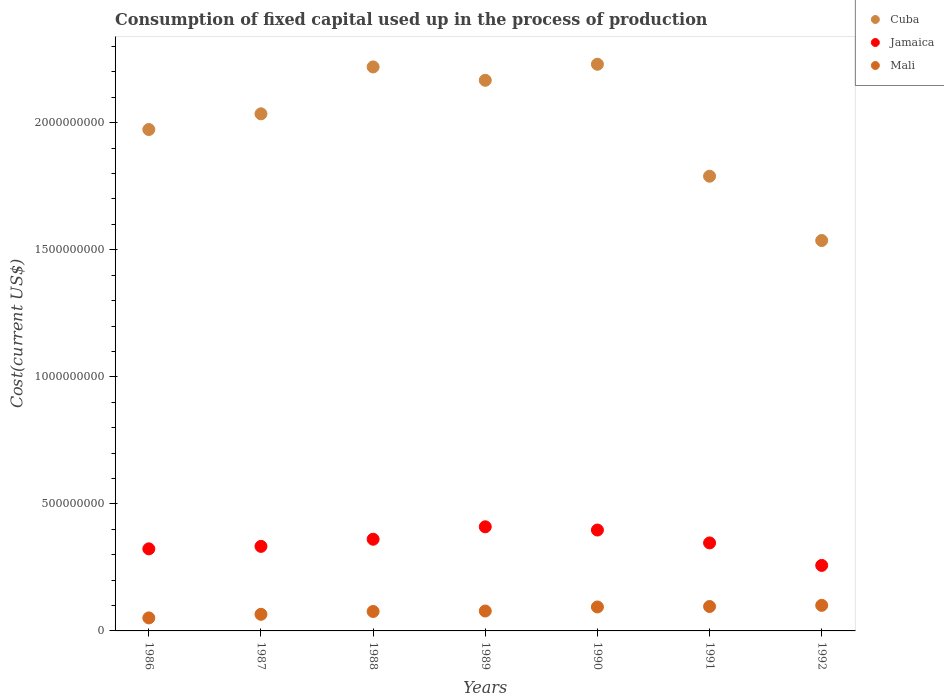Is the number of dotlines equal to the number of legend labels?
Your response must be concise. Yes. What is the amount consumed in the process of production in Mali in 1991?
Provide a short and direct response. 9.61e+07. Across all years, what is the maximum amount consumed in the process of production in Cuba?
Provide a short and direct response. 2.23e+09. Across all years, what is the minimum amount consumed in the process of production in Mali?
Provide a short and direct response. 5.12e+07. In which year was the amount consumed in the process of production in Jamaica maximum?
Your answer should be compact. 1989. What is the total amount consumed in the process of production in Cuba in the graph?
Give a very brief answer. 1.40e+1. What is the difference between the amount consumed in the process of production in Mali in 1989 and that in 1990?
Provide a succinct answer. -1.59e+07. What is the difference between the amount consumed in the process of production in Jamaica in 1988 and the amount consumed in the process of production in Mali in 1989?
Offer a terse response. 2.82e+08. What is the average amount consumed in the process of production in Jamaica per year?
Keep it short and to the point. 3.47e+08. In the year 1988, what is the difference between the amount consumed in the process of production in Jamaica and amount consumed in the process of production in Cuba?
Ensure brevity in your answer.  -1.86e+09. In how many years, is the amount consumed in the process of production in Mali greater than 100000000 US$?
Your response must be concise. 1. What is the ratio of the amount consumed in the process of production in Jamaica in 1986 to that in 1992?
Offer a terse response. 1.25. What is the difference between the highest and the second highest amount consumed in the process of production in Cuba?
Give a very brief answer. 1.05e+07. What is the difference between the highest and the lowest amount consumed in the process of production in Cuba?
Give a very brief answer. 6.94e+08. Is it the case that in every year, the sum of the amount consumed in the process of production in Cuba and amount consumed in the process of production in Mali  is greater than the amount consumed in the process of production in Jamaica?
Offer a terse response. Yes. Does the amount consumed in the process of production in Mali monotonically increase over the years?
Your answer should be compact. Yes. Is the amount consumed in the process of production in Mali strictly greater than the amount consumed in the process of production in Jamaica over the years?
Your response must be concise. No. Is the amount consumed in the process of production in Jamaica strictly less than the amount consumed in the process of production in Mali over the years?
Keep it short and to the point. No. What is the difference between two consecutive major ticks on the Y-axis?
Offer a very short reply. 5.00e+08. Are the values on the major ticks of Y-axis written in scientific E-notation?
Offer a terse response. No. Does the graph contain any zero values?
Provide a succinct answer. No. What is the title of the graph?
Your response must be concise. Consumption of fixed capital used up in the process of production. Does "High income: OECD" appear as one of the legend labels in the graph?
Your response must be concise. No. What is the label or title of the X-axis?
Make the answer very short. Years. What is the label or title of the Y-axis?
Make the answer very short. Cost(current US$). What is the Cost(current US$) of Cuba in 1986?
Make the answer very short. 1.97e+09. What is the Cost(current US$) in Jamaica in 1986?
Provide a short and direct response. 3.23e+08. What is the Cost(current US$) in Mali in 1986?
Make the answer very short. 5.12e+07. What is the Cost(current US$) in Cuba in 1987?
Give a very brief answer. 2.04e+09. What is the Cost(current US$) of Jamaica in 1987?
Offer a very short reply. 3.33e+08. What is the Cost(current US$) of Mali in 1987?
Provide a succinct answer. 6.54e+07. What is the Cost(current US$) of Cuba in 1988?
Offer a terse response. 2.22e+09. What is the Cost(current US$) of Jamaica in 1988?
Make the answer very short. 3.61e+08. What is the Cost(current US$) in Mali in 1988?
Keep it short and to the point. 7.65e+07. What is the Cost(current US$) of Cuba in 1989?
Offer a terse response. 2.17e+09. What is the Cost(current US$) in Jamaica in 1989?
Ensure brevity in your answer.  4.10e+08. What is the Cost(current US$) of Mali in 1989?
Your answer should be compact. 7.84e+07. What is the Cost(current US$) of Cuba in 1990?
Provide a short and direct response. 2.23e+09. What is the Cost(current US$) of Jamaica in 1990?
Ensure brevity in your answer.  3.97e+08. What is the Cost(current US$) in Mali in 1990?
Ensure brevity in your answer.  9.43e+07. What is the Cost(current US$) of Cuba in 1991?
Give a very brief answer. 1.79e+09. What is the Cost(current US$) of Jamaica in 1991?
Offer a very short reply. 3.46e+08. What is the Cost(current US$) in Mali in 1991?
Provide a succinct answer. 9.61e+07. What is the Cost(current US$) in Cuba in 1992?
Your answer should be very brief. 1.54e+09. What is the Cost(current US$) in Jamaica in 1992?
Ensure brevity in your answer.  2.58e+08. What is the Cost(current US$) of Mali in 1992?
Ensure brevity in your answer.  1.01e+08. Across all years, what is the maximum Cost(current US$) of Cuba?
Your answer should be compact. 2.23e+09. Across all years, what is the maximum Cost(current US$) in Jamaica?
Your response must be concise. 4.10e+08. Across all years, what is the maximum Cost(current US$) in Mali?
Offer a terse response. 1.01e+08. Across all years, what is the minimum Cost(current US$) of Cuba?
Your answer should be compact. 1.54e+09. Across all years, what is the minimum Cost(current US$) of Jamaica?
Make the answer very short. 2.58e+08. Across all years, what is the minimum Cost(current US$) of Mali?
Keep it short and to the point. 5.12e+07. What is the total Cost(current US$) of Cuba in the graph?
Provide a succinct answer. 1.40e+1. What is the total Cost(current US$) in Jamaica in the graph?
Keep it short and to the point. 2.43e+09. What is the total Cost(current US$) of Mali in the graph?
Make the answer very short. 5.62e+08. What is the difference between the Cost(current US$) in Cuba in 1986 and that in 1987?
Offer a very short reply. -6.17e+07. What is the difference between the Cost(current US$) in Jamaica in 1986 and that in 1987?
Keep it short and to the point. -9.72e+06. What is the difference between the Cost(current US$) of Mali in 1986 and that in 1987?
Keep it short and to the point. -1.42e+07. What is the difference between the Cost(current US$) in Cuba in 1986 and that in 1988?
Your answer should be very brief. -2.46e+08. What is the difference between the Cost(current US$) of Jamaica in 1986 and that in 1988?
Ensure brevity in your answer.  -3.78e+07. What is the difference between the Cost(current US$) in Mali in 1986 and that in 1988?
Your response must be concise. -2.53e+07. What is the difference between the Cost(current US$) in Cuba in 1986 and that in 1989?
Give a very brief answer. -1.94e+08. What is the difference between the Cost(current US$) of Jamaica in 1986 and that in 1989?
Offer a very short reply. -8.68e+07. What is the difference between the Cost(current US$) of Mali in 1986 and that in 1989?
Your answer should be compact. -2.71e+07. What is the difference between the Cost(current US$) in Cuba in 1986 and that in 1990?
Your answer should be compact. -2.57e+08. What is the difference between the Cost(current US$) in Jamaica in 1986 and that in 1990?
Make the answer very short. -7.40e+07. What is the difference between the Cost(current US$) of Mali in 1986 and that in 1990?
Your answer should be compact. -4.31e+07. What is the difference between the Cost(current US$) of Cuba in 1986 and that in 1991?
Ensure brevity in your answer.  1.84e+08. What is the difference between the Cost(current US$) in Jamaica in 1986 and that in 1991?
Your answer should be compact. -2.33e+07. What is the difference between the Cost(current US$) of Mali in 1986 and that in 1991?
Provide a short and direct response. -4.49e+07. What is the difference between the Cost(current US$) of Cuba in 1986 and that in 1992?
Make the answer very short. 4.37e+08. What is the difference between the Cost(current US$) of Jamaica in 1986 and that in 1992?
Your response must be concise. 6.53e+07. What is the difference between the Cost(current US$) of Mali in 1986 and that in 1992?
Keep it short and to the point. -4.94e+07. What is the difference between the Cost(current US$) in Cuba in 1987 and that in 1988?
Ensure brevity in your answer.  -1.85e+08. What is the difference between the Cost(current US$) of Jamaica in 1987 and that in 1988?
Offer a very short reply. -2.81e+07. What is the difference between the Cost(current US$) in Mali in 1987 and that in 1988?
Your answer should be compact. -1.11e+07. What is the difference between the Cost(current US$) in Cuba in 1987 and that in 1989?
Provide a short and direct response. -1.32e+08. What is the difference between the Cost(current US$) in Jamaica in 1987 and that in 1989?
Your answer should be compact. -7.71e+07. What is the difference between the Cost(current US$) of Mali in 1987 and that in 1989?
Make the answer very short. -1.30e+07. What is the difference between the Cost(current US$) in Cuba in 1987 and that in 1990?
Your answer should be compact. -1.95e+08. What is the difference between the Cost(current US$) in Jamaica in 1987 and that in 1990?
Keep it short and to the point. -6.43e+07. What is the difference between the Cost(current US$) in Mali in 1987 and that in 1990?
Your response must be concise. -2.89e+07. What is the difference between the Cost(current US$) in Cuba in 1987 and that in 1991?
Your answer should be very brief. 2.46e+08. What is the difference between the Cost(current US$) of Jamaica in 1987 and that in 1991?
Your answer should be very brief. -1.36e+07. What is the difference between the Cost(current US$) in Mali in 1987 and that in 1991?
Provide a succinct answer. -3.07e+07. What is the difference between the Cost(current US$) of Cuba in 1987 and that in 1992?
Provide a short and direct response. 4.99e+08. What is the difference between the Cost(current US$) of Jamaica in 1987 and that in 1992?
Give a very brief answer. 7.50e+07. What is the difference between the Cost(current US$) of Mali in 1987 and that in 1992?
Provide a short and direct response. -3.53e+07. What is the difference between the Cost(current US$) of Cuba in 1988 and that in 1989?
Provide a short and direct response. 5.26e+07. What is the difference between the Cost(current US$) of Jamaica in 1988 and that in 1989?
Your answer should be compact. -4.90e+07. What is the difference between the Cost(current US$) in Mali in 1988 and that in 1989?
Provide a succinct answer. -1.85e+06. What is the difference between the Cost(current US$) in Cuba in 1988 and that in 1990?
Your response must be concise. -1.05e+07. What is the difference between the Cost(current US$) in Jamaica in 1988 and that in 1990?
Offer a terse response. -3.62e+07. What is the difference between the Cost(current US$) of Mali in 1988 and that in 1990?
Give a very brief answer. -1.78e+07. What is the difference between the Cost(current US$) of Cuba in 1988 and that in 1991?
Make the answer very short. 4.30e+08. What is the difference between the Cost(current US$) in Jamaica in 1988 and that in 1991?
Your answer should be very brief. 1.45e+07. What is the difference between the Cost(current US$) of Mali in 1988 and that in 1991?
Keep it short and to the point. -1.96e+07. What is the difference between the Cost(current US$) in Cuba in 1988 and that in 1992?
Your response must be concise. 6.83e+08. What is the difference between the Cost(current US$) in Jamaica in 1988 and that in 1992?
Offer a very short reply. 1.03e+08. What is the difference between the Cost(current US$) in Mali in 1988 and that in 1992?
Your response must be concise. -2.41e+07. What is the difference between the Cost(current US$) of Cuba in 1989 and that in 1990?
Your answer should be very brief. -6.31e+07. What is the difference between the Cost(current US$) in Jamaica in 1989 and that in 1990?
Your answer should be very brief. 1.28e+07. What is the difference between the Cost(current US$) in Mali in 1989 and that in 1990?
Your response must be concise. -1.59e+07. What is the difference between the Cost(current US$) in Cuba in 1989 and that in 1991?
Offer a very short reply. 3.77e+08. What is the difference between the Cost(current US$) in Jamaica in 1989 and that in 1991?
Your answer should be compact. 6.35e+07. What is the difference between the Cost(current US$) in Mali in 1989 and that in 1991?
Provide a short and direct response. -1.77e+07. What is the difference between the Cost(current US$) of Cuba in 1989 and that in 1992?
Your answer should be very brief. 6.31e+08. What is the difference between the Cost(current US$) in Jamaica in 1989 and that in 1992?
Your answer should be very brief. 1.52e+08. What is the difference between the Cost(current US$) in Mali in 1989 and that in 1992?
Your answer should be very brief. -2.23e+07. What is the difference between the Cost(current US$) in Cuba in 1990 and that in 1991?
Your answer should be compact. 4.41e+08. What is the difference between the Cost(current US$) in Jamaica in 1990 and that in 1991?
Offer a terse response. 5.07e+07. What is the difference between the Cost(current US$) of Mali in 1990 and that in 1991?
Your response must be concise. -1.78e+06. What is the difference between the Cost(current US$) of Cuba in 1990 and that in 1992?
Offer a terse response. 6.94e+08. What is the difference between the Cost(current US$) of Jamaica in 1990 and that in 1992?
Provide a succinct answer. 1.39e+08. What is the difference between the Cost(current US$) in Mali in 1990 and that in 1992?
Provide a succinct answer. -6.34e+06. What is the difference between the Cost(current US$) of Cuba in 1991 and that in 1992?
Give a very brief answer. 2.53e+08. What is the difference between the Cost(current US$) of Jamaica in 1991 and that in 1992?
Offer a very short reply. 8.86e+07. What is the difference between the Cost(current US$) in Mali in 1991 and that in 1992?
Your response must be concise. -4.56e+06. What is the difference between the Cost(current US$) in Cuba in 1986 and the Cost(current US$) in Jamaica in 1987?
Your answer should be compact. 1.64e+09. What is the difference between the Cost(current US$) of Cuba in 1986 and the Cost(current US$) of Mali in 1987?
Your response must be concise. 1.91e+09. What is the difference between the Cost(current US$) in Jamaica in 1986 and the Cost(current US$) in Mali in 1987?
Make the answer very short. 2.58e+08. What is the difference between the Cost(current US$) of Cuba in 1986 and the Cost(current US$) of Jamaica in 1988?
Your response must be concise. 1.61e+09. What is the difference between the Cost(current US$) of Cuba in 1986 and the Cost(current US$) of Mali in 1988?
Your response must be concise. 1.90e+09. What is the difference between the Cost(current US$) in Jamaica in 1986 and the Cost(current US$) in Mali in 1988?
Make the answer very short. 2.47e+08. What is the difference between the Cost(current US$) in Cuba in 1986 and the Cost(current US$) in Jamaica in 1989?
Your response must be concise. 1.56e+09. What is the difference between the Cost(current US$) of Cuba in 1986 and the Cost(current US$) of Mali in 1989?
Offer a very short reply. 1.90e+09. What is the difference between the Cost(current US$) of Jamaica in 1986 and the Cost(current US$) of Mali in 1989?
Your answer should be very brief. 2.45e+08. What is the difference between the Cost(current US$) in Cuba in 1986 and the Cost(current US$) in Jamaica in 1990?
Offer a terse response. 1.58e+09. What is the difference between the Cost(current US$) of Cuba in 1986 and the Cost(current US$) of Mali in 1990?
Your response must be concise. 1.88e+09. What is the difference between the Cost(current US$) in Jamaica in 1986 and the Cost(current US$) in Mali in 1990?
Make the answer very short. 2.29e+08. What is the difference between the Cost(current US$) in Cuba in 1986 and the Cost(current US$) in Jamaica in 1991?
Offer a very short reply. 1.63e+09. What is the difference between the Cost(current US$) of Cuba in 1986 and the Cost(current US$) of Mali in 1991?
Make the answer very short. 1.88e+09. What is the difference between the Cost(current US$) of Jamaica in 1986 and the Cost(current US$) of Mali in 1991?
Ensure brevity in your answer.  2.27e+08. What is the difference between the Cost(current US$) of Cuba in 1986 and the Cost(current US$) of Jamaica in 1992?
Your answer should be very brief. 1.72e+09. What is the difference between the Cost(current US$) of Cuba in 1986 and the Cost(current US$) of Mali in 1992?
Your answer should be compact. 1.87e+09. What is the difference between the Cost(current US$) of Jamaica in 1986 and the Cost(current US$) of Mali in 1992?
Your answer should be very brief. 2.22e+08. What is the difference between the Cost(current US$) of Cuba in 1987 and the Cost(current US$) of Jamaica in 1988?
Your answer should be compact. 1.67e+09. What is the difference between the Cost(current US$) in Cuba in 1987 and the Cost(current US$) in Mali in 1988?
Make the answer very short. 1.96e+09. What is the difference between the Cost(current US$) in Jamaica in 1987 and the Cost(current US$) in Mali in 1988?
Your response must be concise. 2.56e+08. What is the difference between the Cost(current US$) in Cuba in 1987 and the Cost(current US$) in Jamaica in 1989?
Give a very brief answer. 1.63e+09. What is the difference between the Cost(current US$) in Cuba in 1987 and the Cost(current US$) in Mali in 1989?
Your response must be concise. 1.96e+09. What is the difference between the Cost(current US$) in Jamaica in 1987 and the Cost(current US$) in Mali in 1989?
Make the answer very short. 2.54e+08. What is the difference between the Cost(current US$) in Cuba in 1987 and the Cost(current US$) in Jamaica in 1990?
Offer a very short reply. 1.64e+09. What is the difference between the Cost(current US$) in Cuba in 1987 and the Cost(current US$) in Mali in 1990?
Ensure brevity in your answer.  1.94e+09. What is the difference between the Cost(current US$) of Jamaica in 1987 and the Cost(current US$) of Mali in 1990?
Give a very brief answer. 2.38e+08. What is the difference between the Cost(current US$) of Cuba in 1987 and the Cost(current US$) of Jamaica in 1991?
Ensure brevity in your answer.  1.69e+09. What is the difference between the Cost(current US$) of Cuba in 1987 and the Cost(current US$) of Mali in 1991?
Make the answer very short. 1.94e+09. What is the difference between the Cost(current US$) of Jamaica in 1987 and the Cost(current US$) of Mali in 1991?
Your answer should be compact. 2.37e+08. What is the difference between the Cost(current US$) of Cuba in 1987 and the Cost(current US$) of Jamaica in 1992?
Ensure brevity in your answer.  1.78e+09. What is the difference between the Cost(current US$) of Cuba in 1987 and the Cost(current US$) of Mali in 1992?
Make the answer very short. 1.93e+09. What is the difference between the Cost(current US$) of Jamaica in 1987 and the Cost(current US$) of Mali in 1992?
Give a very brief answer. 2.32e+08. What is the difference between the Cost(current US$) in Cuba in 1988 and the Cost(current US$) in Jamaica in 1989?
Provide a succinct answer. 1.81e+09. What is the difference between the Cost(current US$) of Cuba in 1988 and the Cost(current US$) of Mali in 1989?
Ensure brevity in your answer.  2.14e+09. What is the difference between the Cost(current US$) in Jamaica in 1988 and the Cost(current US$) in Mali in 1989?
Keep it short and to the point. 2.82e+08. What is the difference between the Cost(current US$) of Cuba in 1988 and the Cost(current US$) of Jamaica in 1990?
Your response must be concise. 1.82e+09. What is the difference between the Cost(current US$) of Cuba in 1988 and the Cost(current US$) of Mali in 1990?
Keep it short and to the point. 2.13e+09. What is the difference between the Cost(current US$) in Jamaica in 1988 and the Cost(current US$) in Mali in 1990?
Offer a terse response. 2.67e+08. What is the difference between the Cost(current US$) in Cuba in 1988 and the Cost(current US$) in Jamaica in 1991?
Your answer should be compact. 1.87e+09. What is the difference between the Cost(current US$) in Cuba in 1988 and the Cost(current US$) in Mali in 1991?
Your answer should be compact. 2.12e+09. What is the difference between the Cost(current US$) in Jamaica in 1988 and the Cost(current US$) in Mali in 1991?
Ensure brevity in your answer.  2.65e+08. What is the difference between the Cost(current US$) in Cuba in 1988 and the Cost(current US$) in Jamaica in 1992?
Offer a very short reply. 1.96e+09. What is the difference between the Cost(current US$) of Cuba in 1988 and the Cost(current US$) of Mali in 1992?
Make the answer very short. 2.12e+09. What is the difference between the Cost(current US$) of Jamaica in 1988 and the Cost(current US$) of Mali in 1992?
Give a very brief answer. 2.60e+08. What is the difference between the Cost(current US$) of Cuba in 1989 and the Cost(current US$) of Jamaica in 1990?
Make the answer very short. 1.77e+09. What is the difference between the Cost(current US$) in Cuba in 1989 and the Cost(current US$) in Mali in 1990?
Provide a short and direct response. 2.07e+09. What is the difference between the Cost(current US$) in Jamaica in 1989 and the Cost(current US$) in Mali in 1990?
Provide a short and direct response. 3.16e+08. What is the difference between the Cost(current US$) of Cuba in 1989 and the Cost(current US$) of Jamaica in 1991?
Your answer should be compact. 1.82e+09. What is the difference between the Cost(current US$) in Cuba in 1989 and the Cost(current US$) in Mali in 1991?
Give a very brief answer. 2.07e+09. What is the difference between the Cost(current US$) of Jamaica in 1989 and the Cost(current US$) of Mali in 1991?
Your answer should be compact. 3.14e+08. What is the difference between the Cost(current US$) in Cuba in 1989 and the Cost(current US$) in Jamaica in 1992?
Offer a very short reply. 1.91e+09. What is the difference between the Cost(current US$) in Cuba in 1989 and the Cost(current US$) in Mali in 1992?
Keep it short and to the point. 2.07e+09. What is the difference between the Cost(current US$) in Jamaica in 1989 and the Cost(current US$) in Mali in 1992?
Make the answer very short. 3.09e+08. What is the difference between the Cost(current US$) in Cuba in 1990 and the Cost(current US$) in Jamaica in 1991?
Offer a terse response. 1.88e+09. What is the difference between the Cost(current US$) in Cuba in 1990 and the Cost(current US$) in Mali in 1991?
Offer a very short reply. 2.13e+09. What is the difference between the Cost(current US$) of Jamaica in 1990 and the Cost(current US$) of Mali in 1991?
Ensure brevity in your answer.  3.01e+08. What is the difference between the Cost(current US$) of Cuba in 1990 and the Cost(current US$) of Jamaica in 1992?
Keep it short and to the point. 1.97e+09. What is the difference between the Cost(current US$) of Cuba in 1990 and the Cost(current US$) of Mali in 1992?
Ensure brevity in your answer.  2.13e+09. What is the difference between the Cost(current US$) in Jamaica in 1990 and the Cost(current US$) in Mali in 1992?
Your answer should be compact. 2.96e+08. What is the difference between the Cost(current US$) of Cuba in 1991 and the Cost(current US$) of Jamaica in 1992?
Your answer should be compact. 1.53e+09. What is the difference between the Cost(current US$) in Cuba in 1991 and the Cost(current US$) in Mali in 1992?
Ensure brevity in your answer.  1.69e+09. What is the difference between the Cost(current US$) of Jamaica in 1991 and the Cost(current US$) of Mali in 1992?
Your answer should be compact. 2.46e+08. What is the average Cost(current US$) of Cuba per year?
Provide a short and direct response. 1.99e+09. What is the average Cost(current US$) in Jamaica per year?
Your answer should be very brief. 3.47e+08. What is the average Cost(current US$) in Mali per year?
Your answer should be very brief. 8.04e+07. In the year 1986, what is the difference between the Cost(current US$) of Cuba and Cost(current US$) of Jamaica?
Your response must be concise. 1.65e+09. In the year 1986, what is the difference between the Cost(current US$) of Cuba and Cost(current US$) of Mali?
Keep it short and to the point. 1.92e+09. In the year 1986, what is the difference between the Cost(current US$) of Jamaica and Cost(current US$) of Mali?
Provide a succinct answer. 2.72e+08. In the year 1987, what is the difference between the Cost(current US$) in Cuba and Cost(current US$) in Jamaica?
Keep it short and to the point. 1.70e+09. In the year 1987, what is the difference between the Cost(current US$) of Cuba and Cost(current US$) of Mali?
Offer a terse response. 1.97e+09. In the year 1987, what is the difference between the Cost(current US$) of Jamaica and Cost(current US$) of Mali?
Make the answer very short. 2.67e+08. In the year 1988, what is the difference between the Cost(current US$) in Cuba and Cost(current US$) in Jamaica?
Provide a short and direct response. 1.86e+09. In the year 1988, what is the difference between the Cost(current US$) in Cuba and Cost(current US$) in Mali?
Offer a terse response. 2.14e+09. In the year 1988, what is the difference between the Cost(current US$) of Jamaica and Cost(current US$) of Mali?
Provide a succinct answer. 2.84e+08. In the year 1989, what is the difference between the Cost(current US$) of Cuba and Cost(current US$) of Jamaica?
Make the answer very short. 1.76e+09. In the year 1989, what is the difference between the Cost(current US$) of Cuba and Cost(current US$) of Mali?
Offer a very short reply. 2.09e+09. In the year 1989, what is the difference between the Cost(current US$) in Jamaica and Cost(current US$) in Mali?
Keep it short and to the point. 3.31e+08. In the year 1990, what is the difference between the Cost(current US$) in Cuba and Cost(current US$) in Jamaica?
Keep it short and to the point. 1.83e+09. In the year 1990, what is the difference between the Cost(current US$) of Cuba and Cost(current US$) of Mali?
Your response must be concise. 2.14e+09. In the year 1990, what is the difference between the Cost(current US$) of Jamaica and Cost(current US$) of Mali?
Your answer should be very brief. 3.03e+08. In the year 1991, what is the difference between the Cost(current US$) of Cuba and Cost(current US$) of Jamaica?
Offer a very short reply. 1.44e+09. In the year 1991, what is the difference between the Cost(current US$) of Cuba and Cost(current US$) of Mali?
Provide a succinct answer. 1.69e+09. In the year 1991, what is the difference between the Cost(current US$) of Jamaica and Cost(current US$) of Mali?
Your answer should be compact. 2.50e+08. In the year 1992, what is the difference between the Cost(current US$) in Cuba and Cost(current US$) in Jamaica?
Offer a terse response. 1.28e+09. In the year 1992, what is the difference between the Cost(current US$) of Cuba and Cost(current US$) of Mali?
Provide a succinct answer. 1.44e+09. In the year 1992, what is the difference between the Cost(current US$) in Jamaica and Cost(current US$) in Mali?
Your answer should be compact. 1.57e+08. What is the ratio of the Cost(current US$) in Cuba in 1986 to that in 1987?
Your answer should be very brief. 0.97. What is the ratio of the Cost(current US$) of Jamaica in 1986 to that in 1987?
Your answer should be compact. 0.97. What is the ratio of the Cost(current US$) in Mali in 1986 to that in 1987?
Make the answer very short. 0.78. What is the ratio of the Cost(current US$) of Cuba in 1986 to that in 1988?
Provide a succinct answer. 0.89. What is the ratio of the Cost(current US$) of Jamaica in 1986 to that in 1988?
Provide a succinct answer. 0.9. What is the ratio of the Cost(current US$) in Mali in 1986 to that in 1988?
Your answer should be very brief. 0.67. What is the ratio of the Cost(current US$) in Cuba in 1986 to that in 1989?
Your answer should be very brief. 0.91. What is the ratio of the Cost(current US$) of Jamaica in 1986 to that in 1989?
Your answer should be compact. 0.79. What is the ratio of the Cost(current US$) of Mali in 1986 to that in 1989?
Keep it short and to the point. 0.65. What is the ratio of the Cost(current US$) of Cuba in 1986 to that in 1990?
Give a very brief answer. 0.88. What is the ratio of the Cost(current US$) in Jamaica in 1986 to that in 1990?
Offer a terse response. 0.81. What is the ratio of the Cost(current US$) in Mali in 1986 to that in 1990?
Your response must be concise. 0.54. What is the ratio of the Cost(current US$) in Cuba in 1986 to that in 1991?
Ensure brevity in your answer.  1.1. What is the ratio of the Cost(current US$) in Jamaica in 1986 to that in 1991?
Provide a succinct answer. 0.93. What is the ratio of the Cost(current US$) in Mali in 1986 to that in 1991?
Your response must be concise. 0.53. What is the ratio of the Cost(current US$) of Cuba in 1986 to that in 1992?
Your answer should be very brief. 1.28. What is the ratio of the Cost(current US$) in Jamaica in 1986 to that in 1992?
Make the answer very short. 1.25. What is the ratio of the Cost(current US$) of Mali in 1986 to that in 1992?
Provide a succinct answer. 0.51. What is the ratio of the Cost(current US$) of Cuba in 1987 to that in 1988?
Provide a succinct answer. 0.92. What is the ratio of the Cost(current US$) of Jamaica in 1987 to that in 1988?
Provide a succinct answer. 0.92. What is the ratio of the Cost(current US$) in Mali in 1987 to that in 1988?
Make the answer very short. 0.85. What is the ratio of the Cost(current US$) of Cuba in 1987 to that in 1989?
Make the answer very short. 0.94. What is the ratio of the Cost(current US$) in Jamaica in 1987 to that in 1989?
Your answer should be compact. 0.81. What is the ratio of the Cost(current US$) in Mali in 1987 to that in 1989?
Keep it short and to the point. 0.83. What is the ratio of the Cost(current US$) in Cuba in 1987 to that in 1990?
Keep it short and to the point. 0.91. What is the ratio of the Cost(current US$) in Jamaica in 1987 to that in 1990?
Provide a succinct answer. 0.84. What is the ratio of the Cost(current US$) of Mali in 1987 to that in 1990?
Offer a very short reply. 0.69. What is the ratio of the Cost(current US$) in Cuba in 1987 to that in 1991?
Your answer should be very brief. 1.14. What is the ratio of the Cost(current US$) in Jamaica in 1987 to that in 1991?
Your answer should be very brief. 0.96. What is the ratio of the Cost(current US$) of Mali in 1987 to that in 1991?
Offer a terse response. 0.68. What is the ratio of the Cost(current US$) of Cuba in 1987 to that in 1992?
Provide a succinct answer. 1.32. What is the ratio of the Cost(current US$) in Jamaica in 1987 to that in 1992?
Offer a very short reply. 1.29. What is the ratio of the Cost(current US$) of Mali in 1987 to that in 1992?
Offer a terse response. 0.65. What is the ratio of the Cost(current US$) in Cuba in 1988 to that in 1989?
Provide a succinct answer. 1.02. What is the ratio of the Cost(current US$) of Jamaica in 1988 to that in 1989?
Offer a very short reply. 0.88. What is the ratio of the Cost(current US$) of Mali in 1988 to that in 1989?
Provide a short and direct response. 0.98. What is the ratio of the Cost(current US$) in Jamaica in 1988 to that in 1990?
Your answer should be very brief. 0.91. What is the ratio of the Cost(current US$) of Mali in 1988 to that in 1990?
Ensure brevity in your answer.  0.81. What is the ratio of the Cost(current US$) in Cuba in 1988 to that in 1991?
Keep it short and to the point. 1.24. What is the ratio of the Cost(current US$) of Jamaica in 1988 to that in 1991?
Your answer should be compact. 1.04. What is the ratio of the Cost(current US$) of Mali in 1988 to that in 1991?
Keep it short and to the point. 0.8. What is the ratio of the Cost(current US$) in Cuba in 1988 to that in 1992?
Make the answer very short. 1.44. What is the ratio of the Cost(current US$) of Jamaica in 1988 to that in 1992?
Provide a short and direct response. 1.4. What is the ratio of the Cost(current US$) of Mali in 1988 to that in 1992?
Provide a succinct answer. 0.76. What is the ratio of the Cost(current US$) of Cuba in 1989 to that in 1990?
Make the answer very short. 0.97. What is the ratio of the Cost(current US$) of Jamaica in 1989 to that in 1990?
Give a very brief answer. 1.03. What is the ratio of the Cost(current US$) of Mali in 1989 to that in 1990?
Make the answer very short. 0.83. What is the ratio of the Cost(current US$) of Cuba in 1989 to that in 1991?
Your answer should be very brief. 1.21. What is the ratio of the Cost(current US$) of Jamaica in 1989 to that in 1991?
Your answer should be very brief. 1.18. What is the ratio of the Cost(current US$) in Mali in 1989 to that in 1991?
Your answer should be very brief. 0.82. What is the ratio of the Cost(current US$) in Cuba in 1989 to that in 1992?
Your response must be concise. 1.41. What is the ratio of the Cost(current US$) in Jamaica in 1989 to that in 1992?
Your answer should be very brief. 1.59. What is the ratio of the Cost(current US$) in Mali in 1989 to that in 1992?
Your answer should be compact. 0.78. What is the ratio of the Cost(current US$) in Cuba in 1990 to that in 1991?
Your answer should be very brief. 1.25. What is the ratio of the Cost(current US$) of Jamaica in 1990 to that in 1991?
Offer a terse response. 1.15. What is the ratio of the Cost(current US$) of Mali in 1990 to that in 1991?
Provide a succinct answer. 0.98. What is the ratio of the Cost(current US$) in Cuba in 1990 to that in 1992?
Make the answer very short. 1.45. What is the ratio of the Cost(current US$) of Jamaica in 1990 to that in 1992?
Keep it short and to the point. 1.54. What is the ratio of the Cost(current US$) in Mali in 1990 to that in 1992?
Offer a very short reply. 0.94. What is the ratio of the Cost(current US$) of Cuba in 1991 to that in 1992?
Your response must be concise. 1.16. What is the ratio of the Cost(current US$) of Jamaica in 1991 to that in 1992?
Keep it short and to the point. 1.34. What is the ratio of the Cost(current US$) of Mali in 1991 to that in 1992?
Your response must be concise. 0.95. What is the difference between the highest and the second highest Cost(current US$) of Cuba?
Ensure brevity in your answer.  1.05e+07. What is the difference between the highest and the second highest Cost(current US$) in Jamaica?
Your response must be concise. 1.28e+07. What is the difference between the highest and the second highest Cost(current US$) in Mali?
Offer a very short reply. 4.56e+06. What is the difference between the highest and the lowest Cost(current US$) of Cuba?
Provide a succinct answer. 6.94e+08. What is the difference between the highest and the lowest Cost(current US$) in Jamaica?
Your answer should be compact. 1.52e+08. What is the difference between the highest and the lowest Cost(current US$) in Mali?
Offer a terse response. 4.94e+07. 